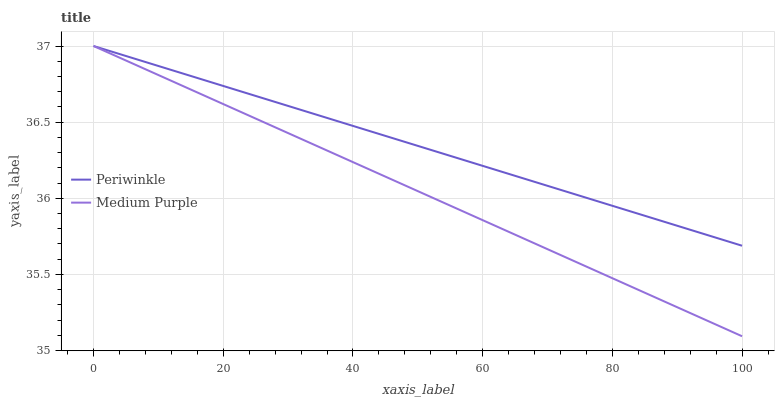Does Periwinkle have the minimum area under the curve?
Answer yes or no. No. Is Periwinkle the smoothest?
Answer yes or no. No. Does Periwinkle have the lowest value?
Answer yes or no. No. 